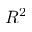<formula> <loc_0><loc_0><loc_500><loc_500>R ^ { 2 }</formula> 